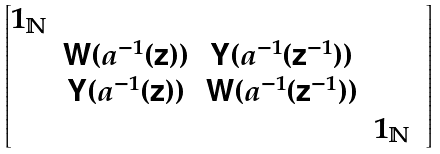<formula> <loc_0><loc_0><loc_500><loc_500>\begin{bmatrix} 1 _ { \mathbb { N } } & & & & \\ & \mathsf W ( a ^ { - 1 } ( \mathsf z ) ) & \mathsf Y ( a ^ { - 1 } ( \mathsf z ^ { - 1 } ) ) & \\ & \mathsf Y ( a ^ { - 1 } ( \mathsf z ) ) & \mathsf W ( a ^ { - 1 } ( \mathsf z ^ { - 1 } ) ) & \\ & & & 1 _ { \mathbb { N } } \end{bmatrix}</formula> 